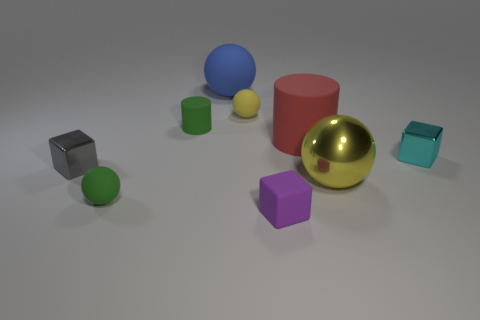There is a small ball in front of the small yellow object; is its color the same as the large thing that is in front of the cyan block?
Make the answer very short. No. What number of matte things are green cylinders or cyan objects?
Your response must be concise. 1. How many yellow spheres are behind the small block that is on the left side of the tiny rubber ball in front of the small yellow ball?
Provide a succinct answer. 1. There is a cyan cube that is made of the same material as the big yellow ball; what size is it?
Give a very brief answer. Small. How many tiny blocks have the same color as the big matte ball?
Your response must be concise. 0. There is a green object behind the green rubber sphere; does it have the same size as the big blue ball?
Ensure brevity in your answer.  No. What color is the object that is both in front of the small green cylinder and behind the cyan cube?
Your response must be concise. Red. How many objects are either yellow matte things or tiny things that are to the left of the small rubber cylinder?
Provide a short and direct response. 3. The small ball right of the large object to the left of the purple object that is left of the red cylinder is made of what material?
Provide a succinct answer. Rubber. Are there any other things that are the same material as the large red object?
Offer a terse response. Yes. 